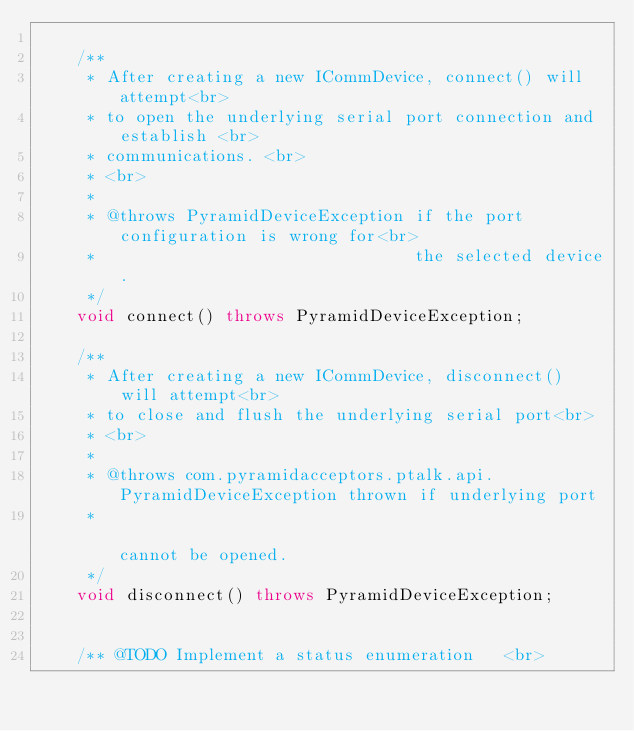Convert code to text. <code><loc_0><loc_0><loc_500><loc_500><_Java_>
    /**
     * After creating a new ICommDevice, connect() will attempt<br>
     * to open the underlying serial port connection and establish <br>
     * communications. <br>
     * <br>
     *
     * @throws PyramidDeviceException if the port configuration is wrong for<br>
     *                                the selected device.
     */
    void connect() throws PyramidDeviceException;

    /**
     * After creating a new ICommDevice, disconnect() will attempt<br>
     * to close and flush the underlying serial port<br>
     * <br>
     *
     * @throws com.pyramidacceptors.ptalk.api.PyramidDeviceException thrown if underlying port
     *                                                               cannot be opened.
     */
    void disconnect() throws PyramidDeviceException;


    /** @TODO Implement a status enumeration   <br></code> 